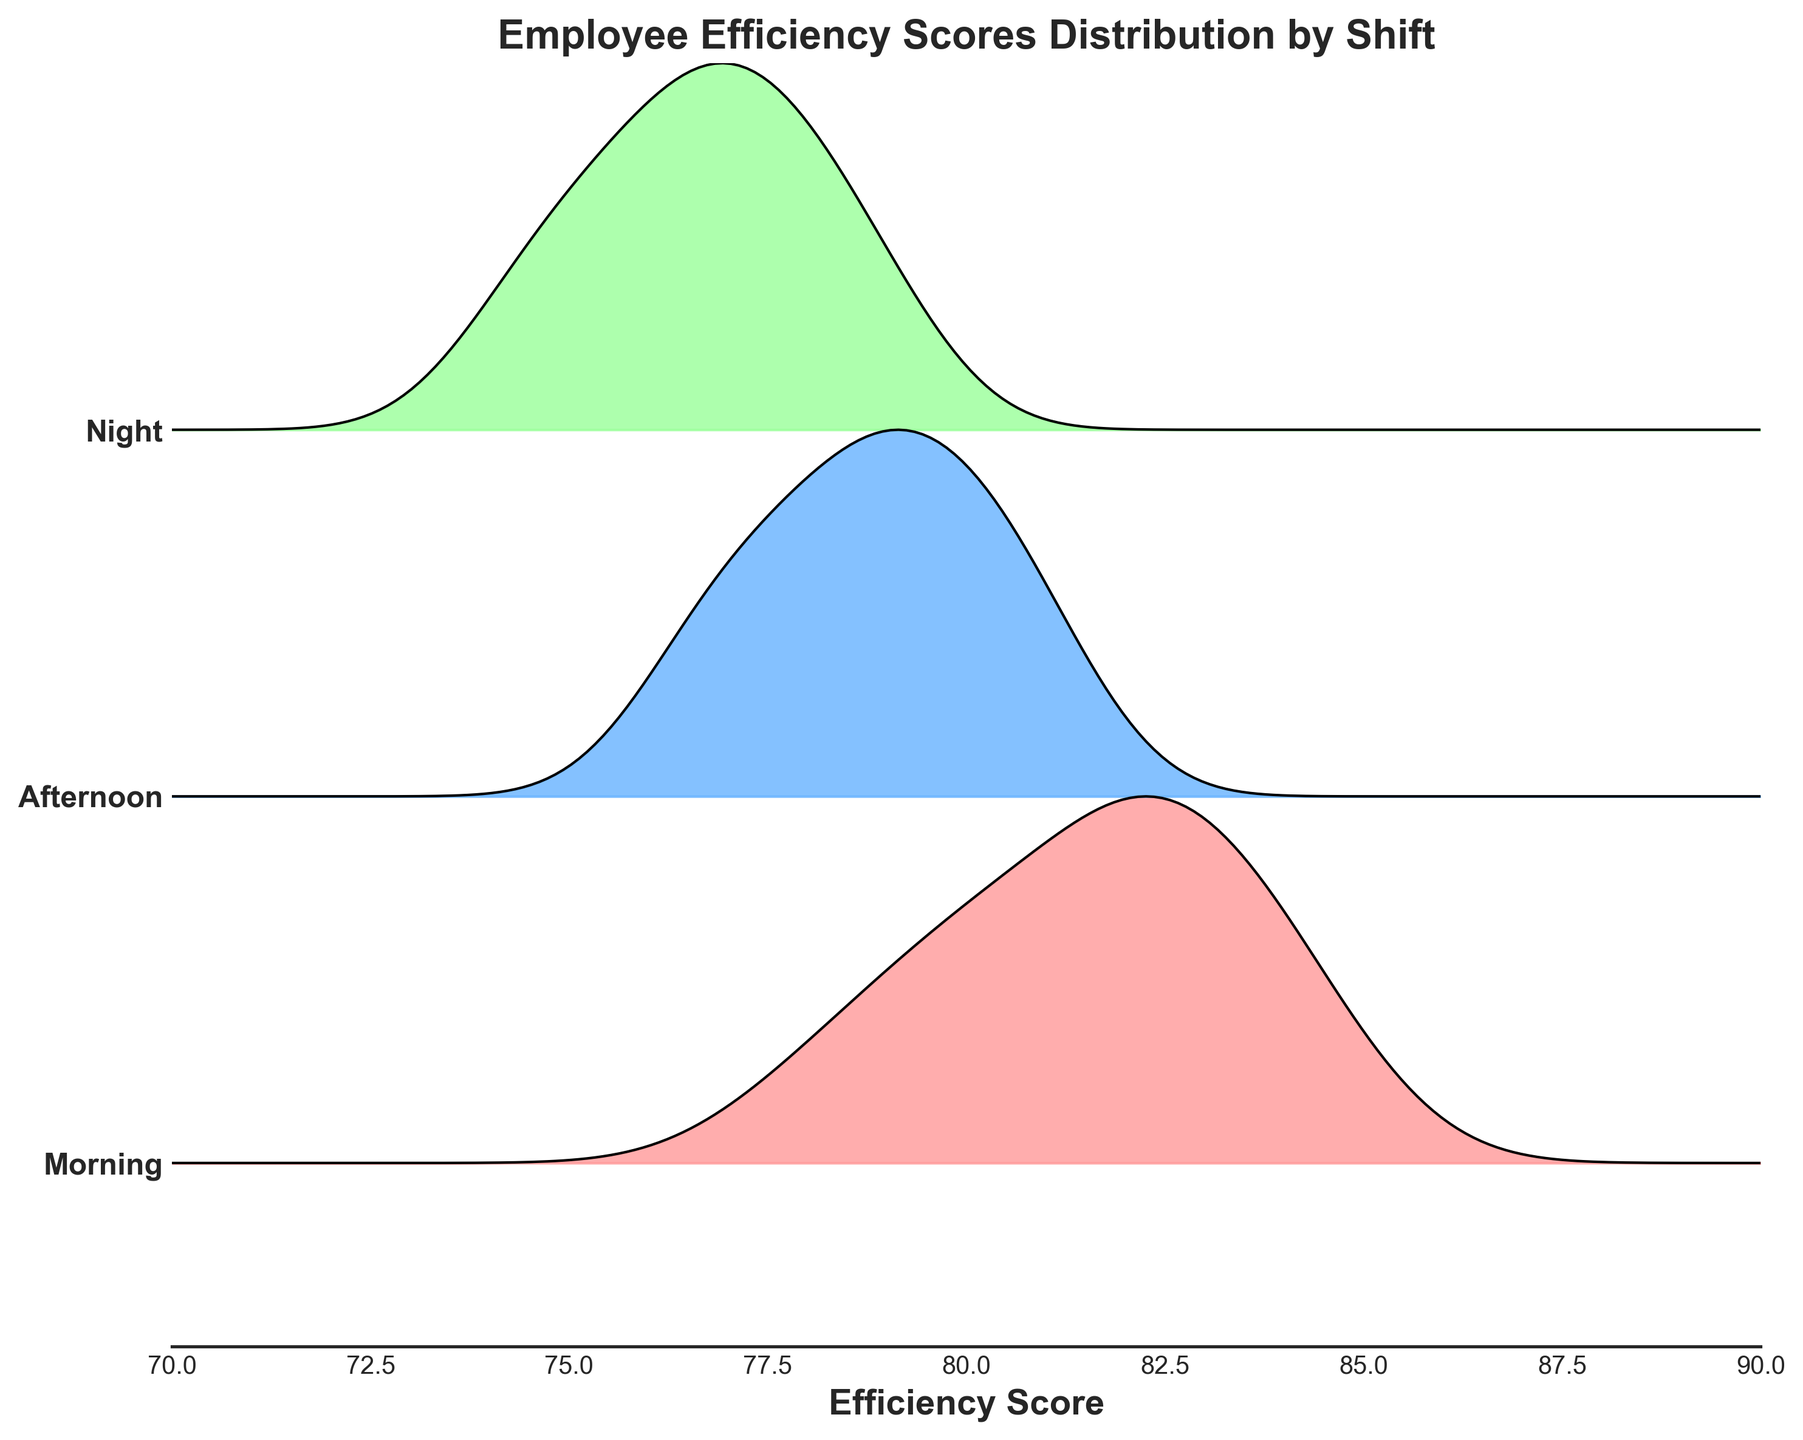What is the title of the figure? The title is clearly given at the top of the figure in bold and larger font compared to other text elements.
Answer: Employee Efficiency Scores Distribution by Shift How many shifts are included in the plot? The y-axis has labeled ticks for each shift, and there are three distinct labels on the y-axis.
Answer: Three (Morning, Afternoon, Night) Which shift appears to have the highest peak efficiency score distribution? The peak of the distribution is the highest point of the curve for each shift. Visually compare the tallest curve across all shifts.
Answer: Morning What is the range of efficiency scores shown on the x-axis? The x-axis label and tick marks show the minimum and maximum values of efficiency scores displayed.
Answer: 70 to 90 How does the efficiency score distribution of the Afternoon shift compare to the Night shift? By looking at the ridgeline plots for Afternoon and Night shifts, compare their highest peaks and the spread of their distributions.
Answer: Afternoon has slightly higher scores Which shift has the broadest distribution of efficiency scores? By examining the width of the distribution curves for each shift from left to right, the broadest curve indicates the widest distribution of scores.
Answer: Night What is the most common efficiency score range for the Morning shift? Analyze the highest peaks and the region around it for the Morning shift's ridgeline to determine where most values are clustered.
Answer: Around 80-85 Which shift has the narrowest distribution in terms of efficiency scores? Compare the width of the curves for each shift to determine which has the smallest spread.
Answer: Morning If you were to improve the efficiency score for the shift with the lowest peaks, which shift would you focus on? Identify the shift with the lowest curves in terms of height to find the one with the lowest efficiency scores.
Answer: Night What can you infer about the overall efficiency of employees across different shifts? By analyzing the height, spread, and central tendency of the ridgeline plots for all shifts, make a general observation about employee efficiency.
Answer: Morning shift employees are generally the most efficient, Night shift employees the least 